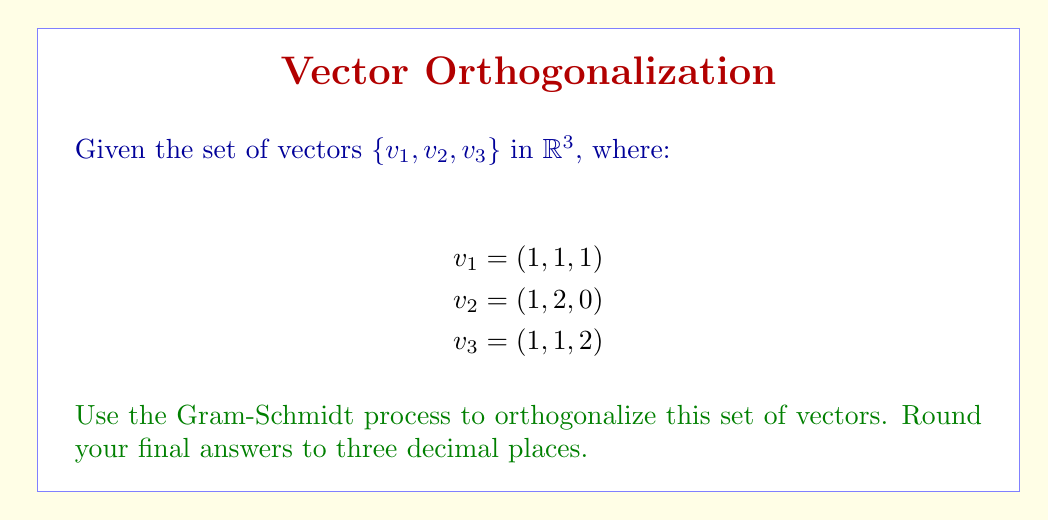Provide a solution to this math problem. Let's apply the Gram-Schmidt process to orthogonalize the given set of vectors:

Step 1: Let $u_1 = v_1$
$$u_1 = (1, 1, 1)$$

Step 2: Calculate $u_2$
$$u_2 = v_2 - \text{proj}_{u_1}(v_2)$$
$$\text{proj}_{u_1}(v_2) = \frac{v_2 \cdot u_1}{u_1 \cdot u_1} u_1 = \frac{(1,2,0) \cdot (1,1,1)}{(1,1,1) \cdot (1,1,1)} (1,1,1) = \frac{3}{3}(1,1,1) = (1,1,1)$$
$$u_2 = (1,2,0) - (1,1,1) = (0,1,-1)$$

Step 3: Calculate $u_3$
$$u_3 = v_3 - \text{proj}_{u_1}(v_3) - \text{proj}_{u_2}(v_3)$$
$$\text{proj}_{u_1}(v_3) = \frac{v_3 \cdot u_1}{u_1 \cdot u_1} u_1 = \frac{(1,1,2) \cdot (1,1,1)}{(1,1,1) \cdot (1,1,1)} (1,1,1) = \frac{4}{3}(1,1,1) = (\frac{4}{3},\frac{4}{3},\frac{4}{3})$$
$$\text{proj}_{u_2}(v_3) = \frac{v_3 \cdot u_2}{u_2 \cdot u_2} u_2 = \frac{(1,1,2) \cdot (0,1,-1)}{(0,1,-1) \cdot (0,1,-1)} (0,1,-1) = \frac{-1}{2}(0,1,-1) = (0,-\frac{1}{2},\frac{1}{2})$$
$$u_3 = (1,1,2) - (\frac{4}{3},\frac{4}{3},\frac{4}{3}) - (0,-\frac{1}{2},\frac{1}{2}) = (-\frac{1}{3},\frac{1}{6},\frac{1}{6})$$

Step 4: Normalize the vectors
$$e_1 = \frac{u_1}{\|u_1\|} = \frac{(1,1,1)}{\sqrt{3}} = (\frac{1}{\sqrt{3}},\frac{1}{\sqrt{3}},\frac{1}{\sqrt{3}}) \approx (0.577, 0.577, 0.577)$$
$$e_2 = \frac{u_2}{\|u_2\|} = \frac{(0,1,-1)}{\sqrt{2}} = (0,\frac{1}{\sqrt{2}},-\frac{1}{\sqrt{2}}) \approx (0, 0.707, -0.707)$$
$$e_3 = \frac{u_3}{\|u_3\|} = \frac{(-\frac{1}{3},\frac{1}{6},\frac{1}{6})}{\sqrt{(\frac{1}{3})^2+(\frac{1}{6})^2+(\frac{1}{6})^2}} = \frac{(-\frac{1}{3},\frac{1}{6},\frac{1}{6})}{\frac{1}{3}\sqrt{3}} = (-1,\frac{1}{2},\frac{1}{2}) \approx (-1.000, 0.500, 0.500)$$
Answer: $e_1 \approx (0.577, 0.577, 0.577)$, $e_2 \approx (0, 0.707, -0.707)$, $e_3 \approx (-1.000, 0.500, 0.500)$ 